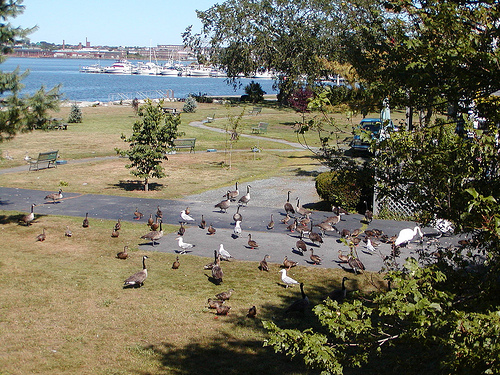<image>
Can you confirm if the bird is under the water? No. The bird is not positioned under the water. The vertical relationship between these objects is different. 